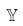<formula> <loc_0><loc_0><loc_500><loc_500>\mathbb { Y }</formula> 